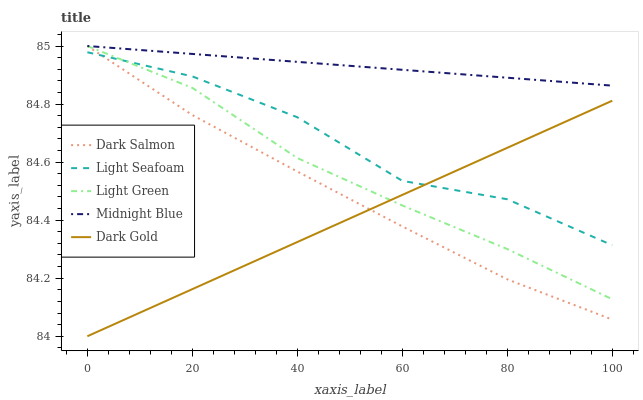Does Dark Gold have the minimum area under the curve?
Answer yes or no. Yes. Does Midnight Blue have the maximum area under the curve?
Answer yes or no. Yes. Does Light Seafoam have the minimum area under the curve?
Answer yes or no. No. Does Light Seafoam have the maximum area under the curve?
Answer yes or no. No. Is Dark Gold the smoothest?
Answer yes or no. Yes. Is Light Seafoam the roughest?
Answer yes or no. Yes. Is Dark Salmon the smoothest?
Answer yes or no. No. Is Dark Salmon the roughest?
Answer yes or no. No. Does Dark Gold have the lowest value?
Answer yes or no. Yes. Does Light Seafoam have the lowest value?
Answer yes or no. No. Does Midnight Blue have the highest value?
Answer yes or no. Yes. Does Light Seafoam have the highest value?
Answer yes or no. No. Is Dark Gold less than Midnight Blue?
Answer yes or no. Yes. Is Midnight Blue greater than Light Seafoam?
Answer yes or no. Yes. Does Dark Salmon intersect Light Seafoam?
Answer yes or no. Yes. Is Dark Salmon less than Light Seafoam?
Answer yes or no. No. Is Dark Salmon greater than Light Seafoam?
Answer yes or no. No. Does Dark Gold intersect Midnight Blue?
Answer yes or no. No. 